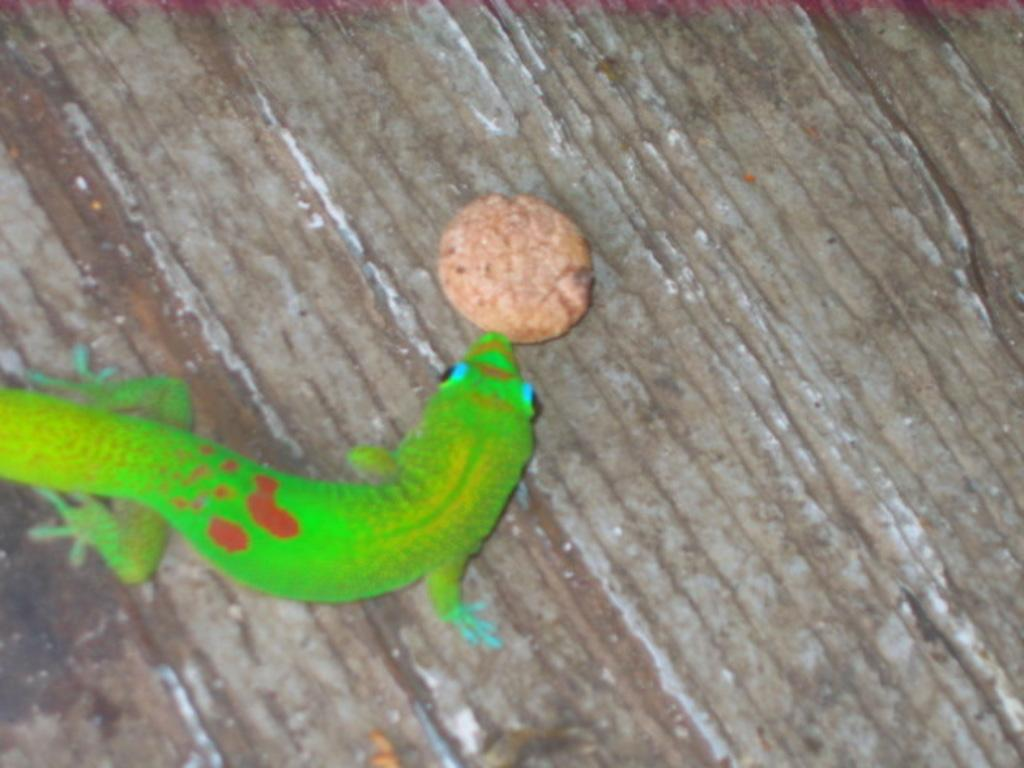What is the main subject in the center of the image? There is a rough object in the center of the image. What is on top of the rough object? There is a lizard and a cookie on the rough object. What is the purpose of the thread in the image? There is no thread present in the image. 